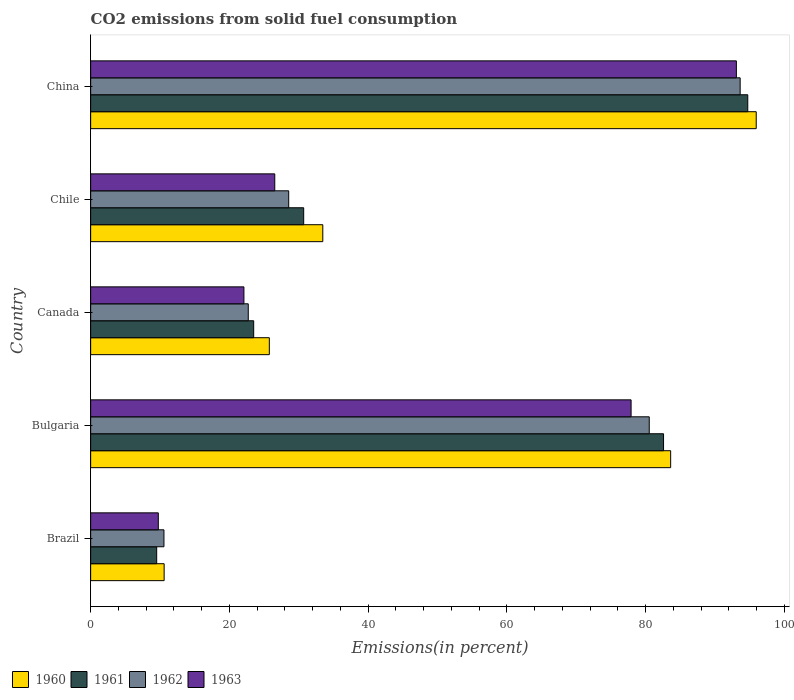How many different coloured bars are there?
Your answer should be very brief. 4. How many groups of bars are there?
Your response must be concise. 5. Are the number of bars on each tick of the Y-axis equal?
Keep it short and to the point. Yes. What is the label of the 5th group of bars from the top?
Ensure brevity in your answer.  Brazil. In how many cases, is the number of bars for a given country not equal to the number of legend labels?
Your answer should be very brief. 0. What is the total CO2 emitted in 1962 in China?
Your answer should be compact. 93.62. Across all countries, what is the maximum total CO2 emitted in 1963?
Give a very brief answer. 93.08. Across all countries, what is the minimum total CO2 emitted in 1962?
Your response must be concise. 10.56. What is the total total CO2 emitted in 1962 in the graph?
Offer a very short reply. 235.97. What is the difference between the total CO2 emitted in 1962 in Chile and that in China?
Keep it short and to the point. -65.07. What is the difference between the total CO2 emitted in 1963 in Chile and the total CO2 emitted in 1960 in China?
Your response must be concise. -69.4. What is the average total CO2 emitted in 1960 per country?
Offer a very short reply. 49.87. What is the difference between the total CO2 emitted in 1961 and total CO2 emitted in 1960 in China?
Ensure brevity in your answer.  -1.22. In how many countries, is the total CO2 emitted in 1963 greater than 12 %?
Offer a very short reply. 4. What is the ratio of the total CO2 emitted in 1960 in Chile to that in China?
Keep it short and to the point. 0.35. Is the total CO2 emitted in 1961 in Brazil less than that in Chile?
Make the answer very short. Yes. What is the difference between the highest and the second highest total CO2 emitted in 1962?
Keep it short and to the point. 13.1. What is the difference between the highest and the lowest total CO2 emitted in 1963?
Ensure brevity in your answer.  83.32. In how many countries, is the total CO2 emitted in 1961 greater than the average total CO2 emitted in 1961 taken over all countries?
Make the answer very short. 2. Is the sum of the total CO2 emitted in 1962 in Canada and China greater than the maximum total CO2 emitted in 1963 across all countries?
Ensure brevity in your answer.  Yes. Is it the case that in every country, the sum of the total CO2 emitted in 1962 and total CO2 emitted in 1961 is greater than the total CO2 emitted in 1960?
Your answer should be compact. Yes. How many bars are there?
Make the answer very short. 20. Are the values on the major ticks of X-axis written in scientific E-notation?
Keep it short and to the point. No. Does the graph contain grids?
Your answer should be very brief. No. Where does the legend appear in the graph?
Ensure brevity in your answer.  Bottom left. How many legend labels are there?
Give a very brief answer. 4. How are the legend labels stacked?
Offer a terse response. Horizontal. What is the title of the graph?
Ensure brevity in your answer.  CO2 emissions from solid fuel consumption. What is the label or title of the X-axis?
Provide a succinct answer. Emissions(in percent). What is the label or title of the Y-axis?
Keep it short and to the point. Country. What is the Emissions(in percent) in 1960 in Brazil?
Provide a succinct answer. 10.59. What is the Emissions(in percent) in 1961 in Brazil?
Ensure brevity in your answer.  9.52. What is the Emissions(in percent) in 1962 in Brazil?
Your response must be concise. 10.56. What is the Emissions(in percent) of 1963 in Brazil?
Your answer should be compact. 9.75. What is the Emissions(in percent) of 1960 in Bulgaria?
Provide a short and direct response. 83.6. What is the Emissions(in percent) in 1961 in Bulgaria?
Make the answer very short. 82.58. What is the Emissions(in percent) in 1962 in Bulgaria?
Ensure brevity in your answer.  80.52. What is the Emissions(in percent) of 1963 in Bulgaria?
Ensure brevity in your answer.  77.9. What is the Emissions(in percent) in 1960 in Canada?
Provide a short and direct response. 25.75. What is the Emissions(in percent) of 1961 in Canada?
Provide a short and direct response. 23.5. What is the Emissions(in percent) of 1962 in Canada?
Offer a terse response. 22.72. What is the Emissions(in percent) in 1963 in Canada?
Make the answer very short. 22.09. What is the Emissions(in percent) of 1960 in Chile?
Make the answer very short. 33.46. What is the Emissions(in percent) in 1961 in Chile?
Offer a very short reply. 30.71. What is the Emissions(in percent) of 1962 in Chile?
Provide a succinct answer. 28.55. What is the Emissions(in percent) in 1963 in Chile?
Your response must be concise. 26.54. What is the Emissions(in percent) of 1960 in China?
Provide a succinct answer. 95.93. What is the Emissions(in percent) of 1961 in China?
Offer a terse response. 94.72. What is the Emissions(in percent) of 1962 in China?
Your response must be concise. 93.62. What is the Emissions(in percent) of 1963 in China?
Keep it short and to the point. 93.08. Across all countries, what is the maximum Emissions(in percent) of 1960?
Keep it short and to the point. 95.93. Across all countries, what is the maximum Emissions(in percent) in 1961?
Your response must be concise. 94.72. Across all countries, what is the maximum Emissions(in percent) in 1962?
Provide a succinct answer. 93.62. Across all countries, what is the maximum Emissions(in percent) of 1963?
Keep it short and to the point. 93.08. Across all countries, what is the minimum Emissions(in percent) in 1960?
Your answer should be very brief. 10.59. Across all countries, what is the minimum Emissions(in percent) in 1961?
Provide a succinct answer. 9.52. Across all countries, what is the minimum Emissions(in percent) in 1962?
Offer a very short reply. 10.56. Across all countries, what is the minimum Emissions(in percent) of 1963?
Your response must be concise. 9.75. What is the total Emissions(in percent) of 1960 in the graph?
Provide a short and direct response. 249.34. What is the total Emissions(in percent) of 1961 in the graph?
Offer a terse response. 241.02. What is the total Emissions(in percent) in 1962 in the graph?
Provide a short and direct response. 235.97. What is the total Emissions(in percent) in 1963 in the graph?
Your answer should be very brief. 229.35. What is the difference between the Emissions(in percent) in 1960 in Brazil and that in Bulgaria?
Your answer should be very brief. -73.01. What is the difference between the Emissions(in percent) in 1961 in Brazil and that in Bulgaria?
Ensure brevity in your answer.  -73.06. What is the difference between the Emissions(in percent) of 1962 in Brazil and that in Bulgaria?
Provide a succinct answer. -69.95. What is the difference between the Emissions(in percent) of 1963 in Brazil and that in Bulgaria?
Your answer should be very brief. -68.15. What is the difference between the Emissions(in percent) in 1960 in Brazil and that in Canada?
Keep it short and to the point. -15.16. What is the difference between the Emissions(in percent) of 1961 in Brazil and that in Canada?
Your response must be concise. -13.98. What is the difference between the Emissions(in percent) of 1962 in Brazil and that in Canada?
Keep it short and to the point. -12.15. What is the difference between the Emissions(in percent) in 1963 in Brazil and that in Canada?
Offer a terse response. -12.34. What is the difference between the Emissions(in percent) of 1960 in Brazil and that in Chile?
Your response must be concise. -22.87. What is the difference between the Emissions(in percent) of 1961 in Brazil and that in Chile?
Ensure brevity in your answer.  -21.19. What is the difference between the Emissions(in percent) in 1962 in Brazil and that in Chile?
Your answer should be very brief. -17.98. What is the difference between the Emissions(in percent) of 1963 in Brazil and that in Chile?
Provide a short and direct response. -16.79. What is the difference between the Emissions(in percent) of 1960 in Brazil and that in China?
Ensure brevity in your answer.  -85.34. What is the difference between the Emissions(in percent) of 1961 in Brazil and that in China?
Keep it short and to the point. -85.2. What is the difference between the Emissions(in percent) in 1962 in Brazil and that in China?
Your answer should be compact. -83.05. What is the difference between the Emissions(in percent) of 1963 in Brazil and that in China?
Give a very brief answer. -83.32. What is the difference between the Emissions(in percent) of 1960 in Bulgaria and that in Canada?
Ensure brevity in your answer.  57.85. What is the difference between the Emissions(in percent) in 1961 in Bulgaria and that in Canada?
Your response must be concise. 59.08. What is the difference between the Emissions(in percent) of 1962 in Bulgaria and that in Canada?
Your answer should be compact. 57.8. What is the difference between the Emissions(in percent) of 1963 in Bulgaria and that in Canada?
Your answer should be very brief. 55.81. What is the difference between the Emissions(in percent) of 1960 in Bulgaria and that in Chile?
Offer a terse response. 50.14. What is the difference between the Emissions(in percent) in 1961 in Bulgaria and that in Chile?
Your answer should be very brief. 51.87. What is the difference between the Emissions(in percent) in 1962 in Bulgaria and that in Chile?
Your response must be concise. 51.97. What is the difference between the Emissions(in percent) in 1963 in Bulgaria and that in Chile?
Ensure brevity in your answer.  51.36. What is the difference between the Emissions(in percent) of 1960 in Bulgaria and that in China?
Offer a terse response. -12.33. What is the difference between the Emissions(in percent) in 1961 in Bulgaria and that in China?
Your answer should be compact. -12.14. What is the difference between the Emissions(in percent) of 1962 in Bulgaria and that in China?
Ensure brevity in your answer.  -13.1. What is the difference between the Emissions(in percent) of 1963 in Bulgaria and that in China?
Provide a succinct answer. -15.18. What is the difference between the Emissions(in percent) of 1960 in Canada and that in Chile?
Ensure brevity in your answer.  -7.71. What is the difference between the Emissions(in percent) in 1961 in Canada and that in Chile?
Your answer should be compact. -7.21. What is the difference between the Emissions(in percent) of 1962 in Canada and that in Chile?
Your response must be concise. -5.83. What is the difference between the Emissions(in percent) in 1963 in Canada and that in Chile?
Your answer should be very brief. -4.45. What is the difference between the Emissions(in percent) of 1960 in Canada and that in China?
Your answer should be compact. -70.18. What is the difference between the Emissions(in percent) of 1961 in Canada and that in China?
Provide a short and direct response. -71.22. What is the difference between the Emissions(in percent) in 1962 in Canada and that in China?
Make the answer very short. -70.9. What is the difference between the Emissions(in percent) in 1963 in Canada and that in China?
Give a very brief answer. -70.98. What is the difference between the Emissions(in percent) of 1960 in Chile and that in China?
Keep it short and to the point. -62.47. What is the difference between the Emissions(in percent) of 1961 in Chile and that in China?
Ensure brevity in your answer.  -64.01. What is the difference between the Emissions(in percent) of 1962 in Chile and that in China?
Your answer should be compact. -65.07. What is the difference between the Emissions(in percent) of 1963 in Chile and that in China?
Your response must be concise. -66.54. What is the difference between the Emissions(in percent) in 1960 in Brazil and the Emissions(in percent) in 1961 in Bulgaria?
Provide a short and direct response. -71.99. What is the difference between the Emissions(in percent) of 1960 in Brazil and the Emissions(in percent) of 1962 in Bulgaria?
Give a very brief answer. -69.93. What is the difference between the Emissions(in percent) of 1960 in Brazil and the Emissions(in percent) of 1963 in Bulgaria?
Keep it short and to the point. -67.31. What is the difference between the Emissions(in percent) of 1961 in Brazil and the Emissions(in percent) of 1962 in Bulgaria?
Provide a short and direct response. -71. What is the difference between the Emissions(in percent) in 1961 in Brazil and the Emissions(in percent) in 1963 in Bulgaria?
Offer a very short reply. -68.38. What is the difference between the Emissions(in percent) of 1962 in Brazil and the Emissions(in percent) of 1963 in Bulgaria?
Offer a very short reply. -67.33. What is the difference between the Emissions(in percent) of 1960 in Brazil and the Emissions(in percent) of 1961 in Canada?
Keep it short and to the point. -12.91. What is the difference between the Emissions(in percent) of 1960 in Brazil and the Emissions(in percent) of 1962 in Canada?
Your answer should be compact. -12.13. What is the difference between the Emissions(in percent) in 1960 in Brazil and the Emissions(in percent) in 1963 in Canada?
Your answer should be very brief. -11.5. What is the difference between the Emissions(in percent) of 1961 in Brazil and the Emissions(in percent) of 1962 in Canada?
Provide a succinct answer. -13.2. What is the difference between the Emissions(in percent) of 1961 in Brazil and the Emissions(in percent) of 1963 in Canada?
Provide a short and direct response. -12.57. What is the difference between the Emissions(in percent) in 1962 in Brazil and the Emissions(in percent) in 1963 in Canada?
Keep it short and to the point. -11.53. What is the difference between the Emissions(in percent) of 1960 in Brazil and the Emissions(in percent) of 1961 in Chile?
Your answer should be compact. -20.11. What is the difference between the Emissions(in percent) in 1960 in Brazil and the Emissions(in percent) in 1962 in Chile?
Your answer should be compact. -17.95. What is the difference between the Emissions(in percent) in 1960 in Brazil and the Emissions(in percent) in 1963 in Chile?
Offer a terse response. -15.94. What is the difference between the Emissions(in percent) of 1961 in Brazil and the Emissions(in percent) of 1962 in Chile?
Make the answer very short. -19.03. What is the difference between the Emissions(in percent) in 1961 in Brazil and the Emissions(in percent) in 1963 in Chile?
Keep it short and to the point. -17.02. What is the difference between the Emissions(in percent) of 1962 in Brazil and the Emissions(in percent) of 1963 in Chile?
Offer a very short reply. -15.97. What is the difference between the Emissions(in percent) of 1960 in Brazil and the Emissions(in percent) of 1961 in China?
Make the answer very short. -84.12. What is the difference between the Emissions(in percent) in 1960 in Brazil and the Emissions(in percent) in 1962 in China?
Offer a terse response. -83.03. What is the difference between the Emissions(in percent) in 1960 in Brazil and the Emissions(in percent) in 1963 in China?
Keep it short and to the point. -82.48. What is the difference between the Emissions(in percent) in 1961 in Brazil and the Emissions(in percent) in 1962 in China?
Your answer should be compact. -84.1. What is the difference between the Emissions(in percent) in 1961 in Brazil and the Emissions(in percent) in 1963 in China?
Offer a very short reply. -83.56. What is the difference between the Emissions(in percent) in 1962 in Brazil and the Emissions(in percent) in 1963 in China?
Make the answer very short. -82.51. What is the difference between the Emissions(in percent) of 1960 in Bulgaria and the Emissions(in percent) of 1961 in Canada?
Offer a terse response. 60.1. What is the difference between the Emissions(in percent) of 1960 in Bulgaria and the Emissions(in percent) of 1962 in Canada?
Your answer should be very brief. 60.88. What is the difference between the Emissions(in percent) of 1960 in Bulgaria and the Emissions(in percent) of 1963 in Canada?
Provide a short and direct response. 61.51. What is the difference between the Emissions(in percent) of 1961 in Bulgaria and the Emissions(in percent) of 1962 in Canada?
Provide a short and direct response. 59.86. What is the difference between the Emissions(in percent) of 1961 in Bulgaria and the Emissions(in percent) of 1963 in Canada?
Provide a succinct answer. 60.49. What is the difference between the Emissions(in percent) of 1962 in Bulgaria and the Emissions(in percent) of 1963 in Canada?
Provide a short and direct response. 58.43. What is the difference between the Emissions(in percent) in 1960 in Bulgaria and the Emissions(in percent) in 1961 in Chile?
Your answer should be compact. 52.9. What is the difference between the Emissions(in percent) of 1960 in Bulgaria and the Emissions(in percent) of 1962 in Chile?
Provide a short and direct response. 55.06. What is the difference between the Emissions(in percent) in 1960 in Bulgaria and the Emissions(in percent) in 1963 in Chile?
Offer a terse response. 57.06. What is the difference between the Emissions(in percent) in 1961 in Bulgaria and the Emissions(in percent) in 1962 in Chile?
Your answer should be compact. 54.03. What is the difference between the Emissions(in percent) of 1961 in Bulgaria and the Emissions(in percent) of 1963 in Chile?
Your answer should be very brief. 56.04. What is the difference between the Emissions(in percent) of 1962 in Bulgaria and the Emissions(in percent) of 1963 in Chile?
Give a very brief answer. 53.98. What is the difference between the Emissions(in percent) in 1960 in Bulgaria and the Emissions(in percent) in 1961 in China?
Your answer should be very brief. -11.12. What is the difference between the Emissions(in percent) of 1960 in Bulgaria and the Emissions(in percent) of 1962 in China?
Ensure brevity in your answer.  -10.02. What is the difference between the Emissions(in percent) of 1960 in Bulgaria and the Emissions(in percent) of 1963 in China?
Offer a very short reply. -9.47. What is the difference between the Emissions(in percent) in 1961 in Bulgaria and the Emissions(in percent) in 1962 in China?
Your answer should be very brief. -11.04. What is the difference between the Emissions(in percent) of 1961 in Bulgaria and the Emissions(in percent) of 1963 in China?
Provide a succinct answer. -10.5. What is the difference between the Emissions(in percent) in 1962 in Bulgaria and the Emissions(in percent) in 1963 in China?
Make the answer very short. -12.56. What is the difference between the Emissions(in percent) in 1960 in Canada and the Emissions(in percent) in 1961 in Chile?
Your answer should be compact. -4.95. What is the difference between the Emissions(in percent) of 1960 in Canada and the Emissions(in percent) of 1962 in Chile?
Make the answer very short. -2.79. What is the difference between the Emissions(in percent) of 1960 in Canada and the Emissions(in percent) of 1963 in Chile?
Provide a short and direct response. -0.78. What is the difference between the Emissions(in percent) in 1961 in Canada and the Emissions(in percent) in 1962 in Chile?
Provide a succinct answer. -5.05. What is the difference between the Emissions(in percent) of 1961 in Canada and the Emissions(in percent) of 1963 in Chile?
Your answer should be very brief. -3.04. What is the difference between the Emissions(in percent) in 1962 in Canada and the Emissions(in percent) in 1963 in Chile?
Provide a short and direct response. -3.82. What is the difference between the Emissions(in percent) in 1960 in Canada and the Emissions(in percent) in 1961 in China?
Give a very brief answer. -68.96. What is the difference between the Emissions(in percent) of 1960 in Canada and the Emissions(in percent) of 1962 in China?
Give a very brief answer. -67.87. What is the difference between the Emissions(in percent) of 1960 in Canada and the Emissions(in percent) of 1963 in China?
Give a very brief answer. -67.32. What is the difference between the Emissions(in percent) of 1961 in Canada and the Emissions(in percent) of 1962 in China?
Provide a succinct answer. -70.12. What is the difference between the Emissions(in percent) of 1961 in Canada and the Emissions(in percent) of 1963 in China?
Your answer should be compact. -69.58. What is the difference between the Emissions(in percent) in 1962 in Canada and the Emissions(in percent) in 1963 in China?
Your answer should be compact. -70.36. What is the difference between the Emissions(in percent) of 1960 in Chile and the Emissions(in percent) of 1961 in China?
Provide a succinct answer. -61.26. What is the difference between the Emissions(in percent) of 1960 in Chile and the Emissions(in percent) of 1962 in China?
Offer a terse response. -60.16. What is the difference between the Emissions(in percent) of 1960 in Chile and the Emissions(in percent) of 1963 in China?
Your response must be concise. -59.62. What is the difference between the Emissions(in percent) of 1961 in Chile and the Emissions(in percent) of 1962 in China?
Your answer should be compact. -62.91. What is the difference between the Emissions(in percent) of 1961 in Chile and the Emissions(in percent) of 1963 in China?
Offer a very short reply. -62.37. What is the difference between the Emissions(in percent) in 1962 in Chile and the Emissions(in percent) in 1963 in China?
Your answer should be very brief. -64.53. What is the average Emissions(in percent) of 1960 per country?
Ensure brevity in your answer.  49.87. What is the average Emissions(in percent) in 1961 per country?
Give a very brief answer. 48.2. What is the average Emissions(in percent) of 1962 per country?
Offer a terse response. 47.19. What is the average Emissions(in percent) in 1963 per country?
Ensure brevity in your answer.  45.87. What is the difference between the Emissions(in percent) in 1960 and Emissions(in percent) in 1961 in Brazil?
Your answer should be compact. 1.08. What is the difference between the Emissions(in percent) in 1960 and Emissions(in percent) in 1962 in Brazil?
Give a very brief answer. 0.03. What is the difference between the Emissions(in percent) in 1960 and Emissions(in percent) in 1963 in Brazil?
Provide a short and direct response. 0.84. What is the difference between the Emissions(in percent) in 1961 and Emissions(in percent) in 1962 in Brazil?
Your response must be concise. -1.05. What is the difference between the Emissions(in percent) in 1961 and Emissions(in percent) in 1963 in Brazil?
Make the answer very short. -0.23. What is the difference between the Emissions(in percent) of 1962 and Emissions(in percent) of 1963 in Brazil?
Offer a very short reply. 0.81. What is the difference between the Emissions(in percent) in 1960 and Emissions(in percent) in 1962 in Bulgaria?
Offer a terse response. 3.08. What is the difference between the Emissions(in percent) in 1960 and Emissions(in percent) in 1963 in Bulgaria?
Keep it short and to the point. 5.7. What is the difference between the Emissions(in percent) of 1961 and Emissions(in percent) of 1962 in Bulgaria?
Give a very brief answer. 2.06. What is the difference between the Emissions(in percent) in 1961 and Emissions(in percent) in 1963 in Bulgaria?
Ensure brevity in your answer.  4.68. What is the difference between the Emissions(in percent) of 1962 and Emissions(in percent) of 1963 in Bulgaria?
Provide a short and direct response. 2.62. What is the difference between the Emissions(in percent) in 1960 and Emissions(in percent) in 1961 in Canada?
Ensure brevity in your answer.  2.25. What is the difference between the Emissions(in percent) in 1960 and Emissions(in percent) in 1962 in Canada?
Offer a very short reply. 3.03. What is the difference between the Emissions(in percent) of 1960 and Emissions(in percent) of 1963 in Canada?
Provide a succinct answer. 3.66. What is the difference between the Emissions(in percent) of 1961 and Emissions(in percent) of 1962 in Canada?
Provide a short and direct response. 0.78. What is the difference between the Emissions(in percent) in 1961 and Emissions(in percent) in 1963 in Canada?
Keep it short and to the point. 1.41. What is the difference between the Emissions(in percent) in 1962 and Emissions(in percent) in 1963 in Canada?
Offer a terse response. 0.63. What is the difference between the Emissions(in percent) in 1960 and Emissions(in percent) in 1961 in Chile?
Make the answer very short. 2.75. What is the difference between the Emissions(in percent) in 1960 and Emissions(in percent) in 1962 in Chile?
Make the answer very short. 4.91. What is the difference between the Emissions(in percent) of 1960 and Emissions(in percent) of 1963 in Chile?
Your response must be concise. 6.92. What is the difference between the Emissions(in percent) in 1961 and Emissions(in percent) in 1962 in Chile?
Keep it short and to the point. 2.16. What is the difference between the Emissions(in percent) in 1961 and Emissions(in percent) in 1963 in Chile?
Make the answer very short. 4.17. What is the difference between the Emissions(in percent) of 1962 and Emissions(in percent) of 1963 in Chile?
Offer a terse response. 2.01. What is the difference between the Emissions(in percent) in 1960 and Emissions(in percent) in 1961 in China?
Your answer should be very brief. 1.22. What is the difference between the Emissions(in percent) in 1960 and Emissions(in percent) in 1962 in China?
Provide a short and direct response. 2.32. What is the difference between the Emissions(in percent) of 1960 and Emissions(in percent) of 1963 in China?
Provide a succinct answer. 2.86. What is the difference between the Emissions(in percent) in 1961 and Emissions(in percent) in 1962 in China?
Make the answer very short. 1.1. What is the difference between the Emissions(in percent) of 1961 and Emissions(in percent) of 1963 in China?
Your answer should be compact. 1.64. What is the difference between the Emissions(in percent) in 1962 and Emissions(in percent) in 1963 in China?
Provide a succinct answer. 0.54. What is the ratio of the Emissions(in percent) in 1960 in Brazil to that in Bulgaria?
Provide a succinct answer. 0.13. What is the ratio of the Emissions(in percent) of 1961 in Brazil to that in Bulgaria?
Your answer should be very brief. 0.12. What is the ratio of the Emissions(in percent) in 1962 in Brazil to that in Bulgaria?
Provide a succinct answer. 0.13. What is the ratio of the Emissions(in percent) in 1963 in Brazil to that in Bulgaria?
Offer a terse response. 0.13. What is the ratio of the Emissions(in percent) in 1960 in Brazil to that in Canada?
Give a very brief answer. 0.41. What is the ratio of the Emissions(in percent) in 1961 in Brazil to that in Canada?
Keep it short and to the point. 0.41. What is the ratio of the Emissions(in percent) in 1962 in Brazil to that in Canada?
Provide a short and direct response. 0.47. What is the ratio of the Emissions(in percent) in 1963 in Brazil to that in Canada?
Ensure brevity in your answer.  0.44. What is the ratio of the Emissions(in percent) of 1960 in Brazil to that in Chile?
Provide a short and direct response. 0.32. What is the ratio of the Emissions(in percent) in 1961 in Brazil to that in Chile?
Provide a short and direct response. 0.31. What is the ratio of the Emissions(in percent) in 1962 in Brazil to that in Chile?
Your answer should be compact. 0.37. What is the ratio of the Emissions(in percent) in 1963 in Brazil to that in Chile?
Provide a short and direct response. 0.37. What is the ratio of the Emissions(in percent) in 1960 in Brazil to that in China?
Ensure brevity in your answer.  0.11. What is the ratio of the Emissions(in percent) of 1961 in Brazil to that in China?
Ensure brevity in your answer.  0.1. What is the ratio of the Emissions(in percent) of 1962 in Brazil to that in China?
Give a very brief answer. 0.11. What is the ratio of the Emissions(in percent) in 1963 in Brazil to that in China?
Your answer should be compact. 0.1. What is the ratio of the Emissions(in percent) in 1960 in Bulgaria to that in Canada?
Give a very brief answer. 3.25. What is the ratio of the Emissions(in percent) in 1961 in Bulgaria to that in Canada?
Make the answer very short. 3.51. What is the ratio of the Emissions(in percent) in 1962 in Bulgaria to that in Canada?
Provide a short and direct response. 3.54. What is the ratio of the Emissions(in percent) in 1963 in Bulgaria to that in Canada?
Offer a very short reply. 3.53. What is the ratio of the Emissions(in percent) in 1960 in Bulgaria to that in Chile?
Your answer should be very brief. 2.5. What is the ratio of the Emissions(in percent) of 1961 in Bulgaria to that in Chile?
Your response must be concise. 2.69. What is the ratio of the Emissions(in percent) of 1962 in Bulgaria to that in Chile?
Your response must be concise. 2.82. What is the ratio of the Emissions(in percent) of 1963 in Bulgaria to that in Chile?
Make the answer very short. 2.94. What is the ratio of the Emissions(in percent) in 1960 in Bulgaria to that in China?
Your answer should be very brief. 0.87. What is the ratio of the Emissions(in percent) of 1961 in Bulgaria to that in China?
Give a very brief answer. 0.87. What is the ratio of the Emissions(in percent) of 1962 in Bulgaria to that in China?
Provide a succinct answer. 0.86. What is the ratio of the Emissions(in percent) of 1963 in Bulgaria to that in China?
Offer a terse response. 0.84. What is the ratio of the Emissions(in percent) of 1960 in Canada to that in Chile?
Keep it short and to the point. 0.77. What is the ratio of the Emissions(in percent) of 1961 in Canada to that in Chile?
Keep it short and to the point. 0.77. What is the ratio of the Emissions(in percent) in 1962 in Canada to that in Chile?
Offer a very short reply. 0.8. What is the ratio of the Emissions(in percent) in 1963 in Canada to that in Chile?
Your answer should be very brief. 0.83. What is the ratio of the Emissions(in percent) of 1960 in Canada to that in China?
Make the answer very short. 0.27. What is the ratio of the Emissions(in percent) of 1961 in Canada to that in China?
Make the answer very short. 0.25. What is the ratio of the Emissions(in percent) in 1962 in Canada to that in China?
Provide a short and direct response. 0.24. What is the ratio of the Emissions(in percent) in 1963 in Canada to that in China?
Your answer should be compact. 0.24. What is the ratio of the Emissions(in percent) of 1960 in Chile to that in China?
Your answer should be compact. 0.35. What is the ratio of the Emissions(in percent) of 1961 in Chile to that in China?
Ensure brevity in your answer.  0.32. What is the ratio of the Emissions(in percent) of 1962 in Chile to that in China?
Make the answer very short. 0.3. What is the ratio of the Emissions(in percent) in 1963 in Chile to that in China?
Your answer should be very brief. 0.29. What is the difference between the highest and the second highest Emissions(in percent) in 1960?
Give a very brief answer. 12.33. What is the difference between the highest and the second highest Emissions(in percent) in 1961?
Provide a short and direct response. 12.14. What is the difference between the highest and the second highest Emissions(in percent) in 1962?
Give a very brief answer. 13.1. What is the difference between the highest and the second highest Emissions(in percent) of 1963?
Give a very brief answer. 15.18. What is the difference between the highest and the lowest Emissions(in percent) in 1960?
Give a very brief answer. 85.34. What is the difference between the highest and the lowest Emissions(in percent) of 1961?
Offer a very short reply. 85.2. What is the difference between the highest and the lowest Emissions(in percent) of 1962?
Provide a short and direct response. 83.05. What is the difference between the highest and the lowest Emissions(in percent) in 1963?
Provide a short and direct response. 83.32. 